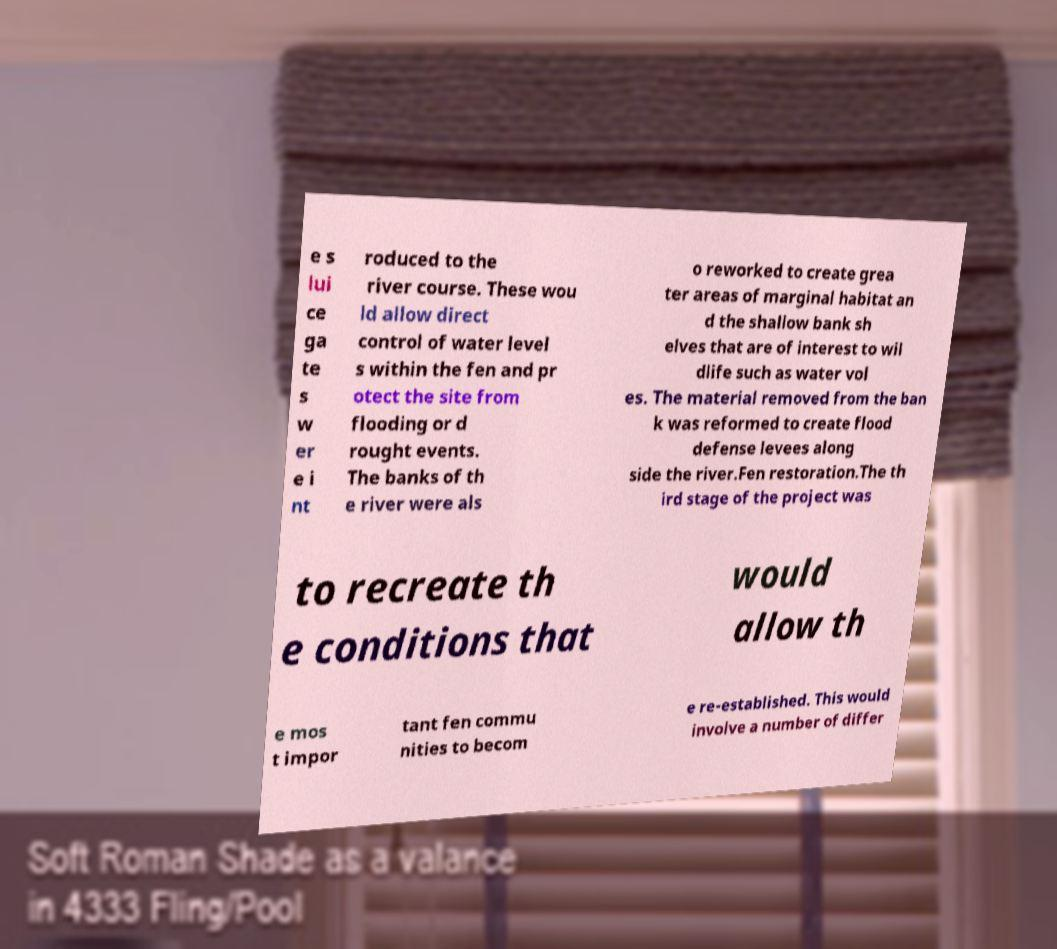For documentation purposes, I need the text within this image transcribed. Could you provide that? e s lui ce ga te s w er e i nt roduced to the river course. These wou ld allow direct control of water level s within the fen and pr otect the site from flooding or d rought events. The banks of th e river were als o reworked to create grea ter areas of marginal habitat an d the shallow bank sh elves that are of interest to wil dlife such as water vol es. The material removed from the ban k was reformed to create flood defense levees along side the river.Fen restoration.The th ird stage of the project was to recreate th e conditions that would allow th e mos t impor tant fen commu nities to becom e re-established. This would involve a number of differ 